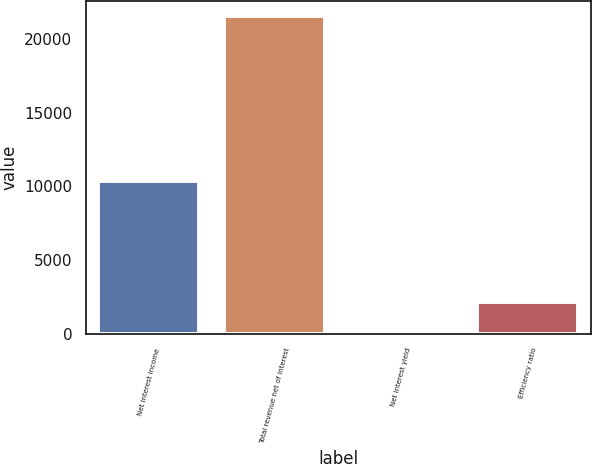Convert chart. <chart><loc_0><loc_0><loc_500><loc_500><bar_chart><fcel>Net interest income<fcel>Total revenue net of interest<fcel>Net interest yield<fcel>Efficiency ratio<nl><fcel>10341<fcel>21509<fcel>2.23<fcel>2152.91<nl></chart> 